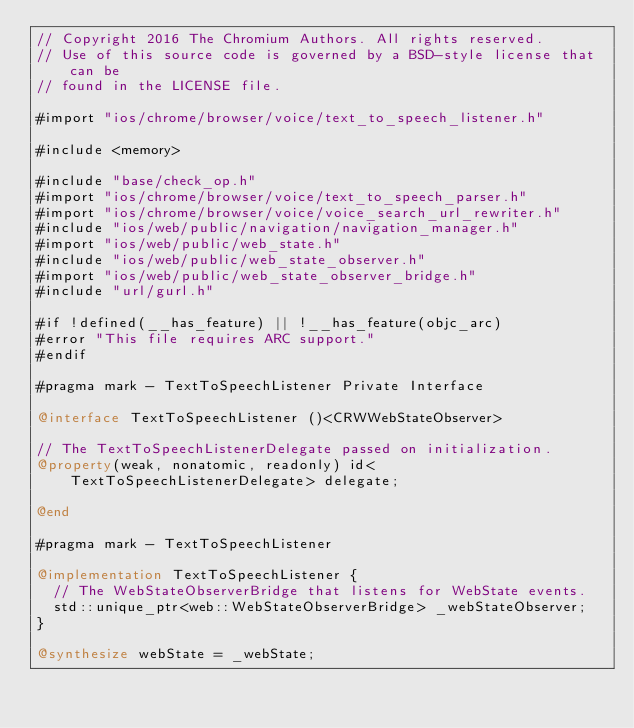<code> <loc_0><loc_0><loc_500><loc_500><_ObjectiveC_>// Copyright 2016 The Chromium Authors. All rights reserved.
// Use of this source code is governed by a BSD-style license that can be
// found in the LICENSE file.

#import "ios/chrome/browser/voice/text_to_speech_listener.h"

#include <memory>

#include "base/check_op.h"
#import "ios/chrome/browser/voice/text_to_speech_parser.h"
#import "ios/chrome/browser/voice/voice_search_url_rewriter.h"
#include "ios/web/public/navigation/navigation_manager.h"
#import "ios/web/public/web_state.h"
#include "ios/web/public/web_state_observer.h"
#import "ios/web/public/web_state_observer_bridge.h"
#include "url/gurl.h"

#if !defined(__has_feature) || !__has_feature(objc_arc)
#error "This file requires ARC support."
#endif

#pragma mark - TextToSpeechListener Private Interface

@interface TextToSpeechListener ()<CRWWebStateObserver>

// The TextToSpeechListenerDelegate passed on initialization.
@property(weak, nonatomic, readonly) id<TextToSpeechListenerDelegate> delegate;

@end

#pragma mark - TextToSpeechListener

@implementation TextToSpeechListener {
  // The WebStateObserverBridge that listens for WebState events.
  std::unique_ptr<web::WebStateObserverBridge> _webStateObserver;
}

@synthesize webState = _webState;</code> 